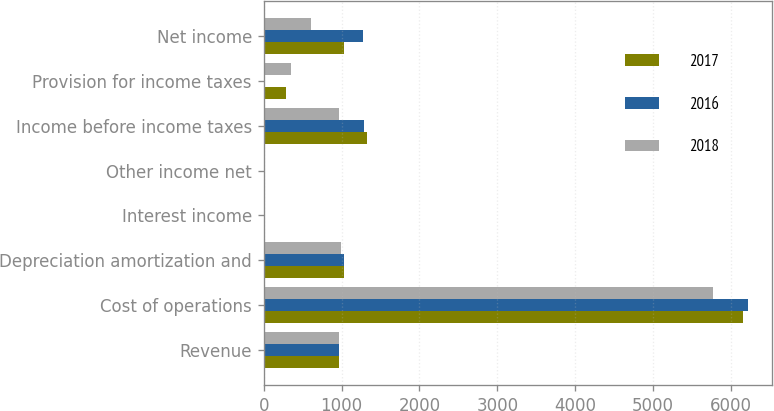Convert chart to OTSL. <chart><loc_0><loc_0><loc_500><loc_500><stacked_bar_chart><ecel><fcel>Revenue<fcel>Cost of operations<fcel>Depreciation amortization and<fcel>Interest income<fcel>Other income net<fcel>Income before income taxes<fcel>Provision for income taxes<fcel>Net income<nl><fcel>2017<fcel>965.9<fcel>6150<fcel>1033.4<fcel>1.6<fcel>3.4<fcel>1320.9<fcel>283.3<fcel>1037.6<nl><fcel>2016<fcel>965.9<fcel>6214.6<fcel>1036.3<fcel>1<fcel>2.7<fcel>1282.1<fcel>3.1<fcel>1279<nl><fcel>2018<fcel>965.9<fcel>5764<fcel>991.1<fcel>0.9<fcel>1.1<fcel>965.9<fcel>352.7<fcel>613.2<nl></chart> 